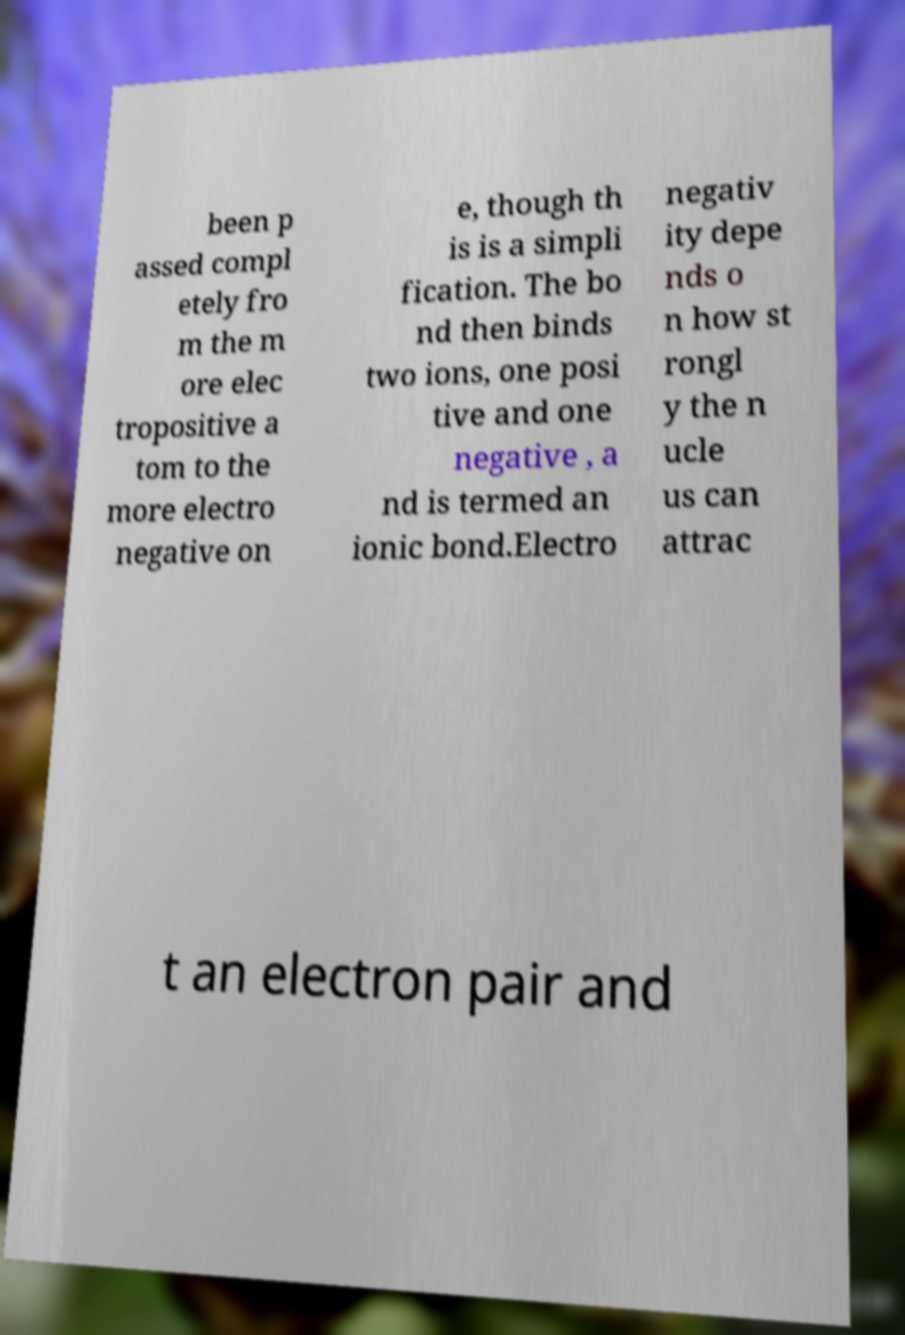Can you accurately transcribe the text from the provided image for me? been p assed compl etely fro m the m ore elec tropositive a tom to the more electro negative on e, though th is is a simpli fication. The bo nd then binds two ions, one posi tive and one negative , a nd is termed an ionic bond.Electro negativ ity depe nds o n how st rongl y the n ucle us can attrac t an electron pair and 